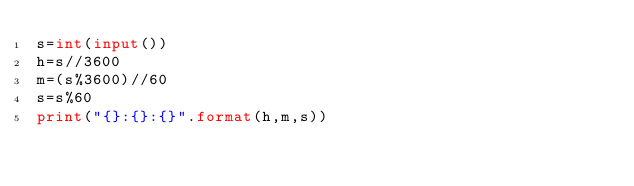<code> <loc_0><loc_0><loc_500><loc_500><_Python_>s=int(input())
h=s//3600
m=(s%3600)//60
s=s%60
print("{}:{}:{}".format(h,m,s))
</code> 